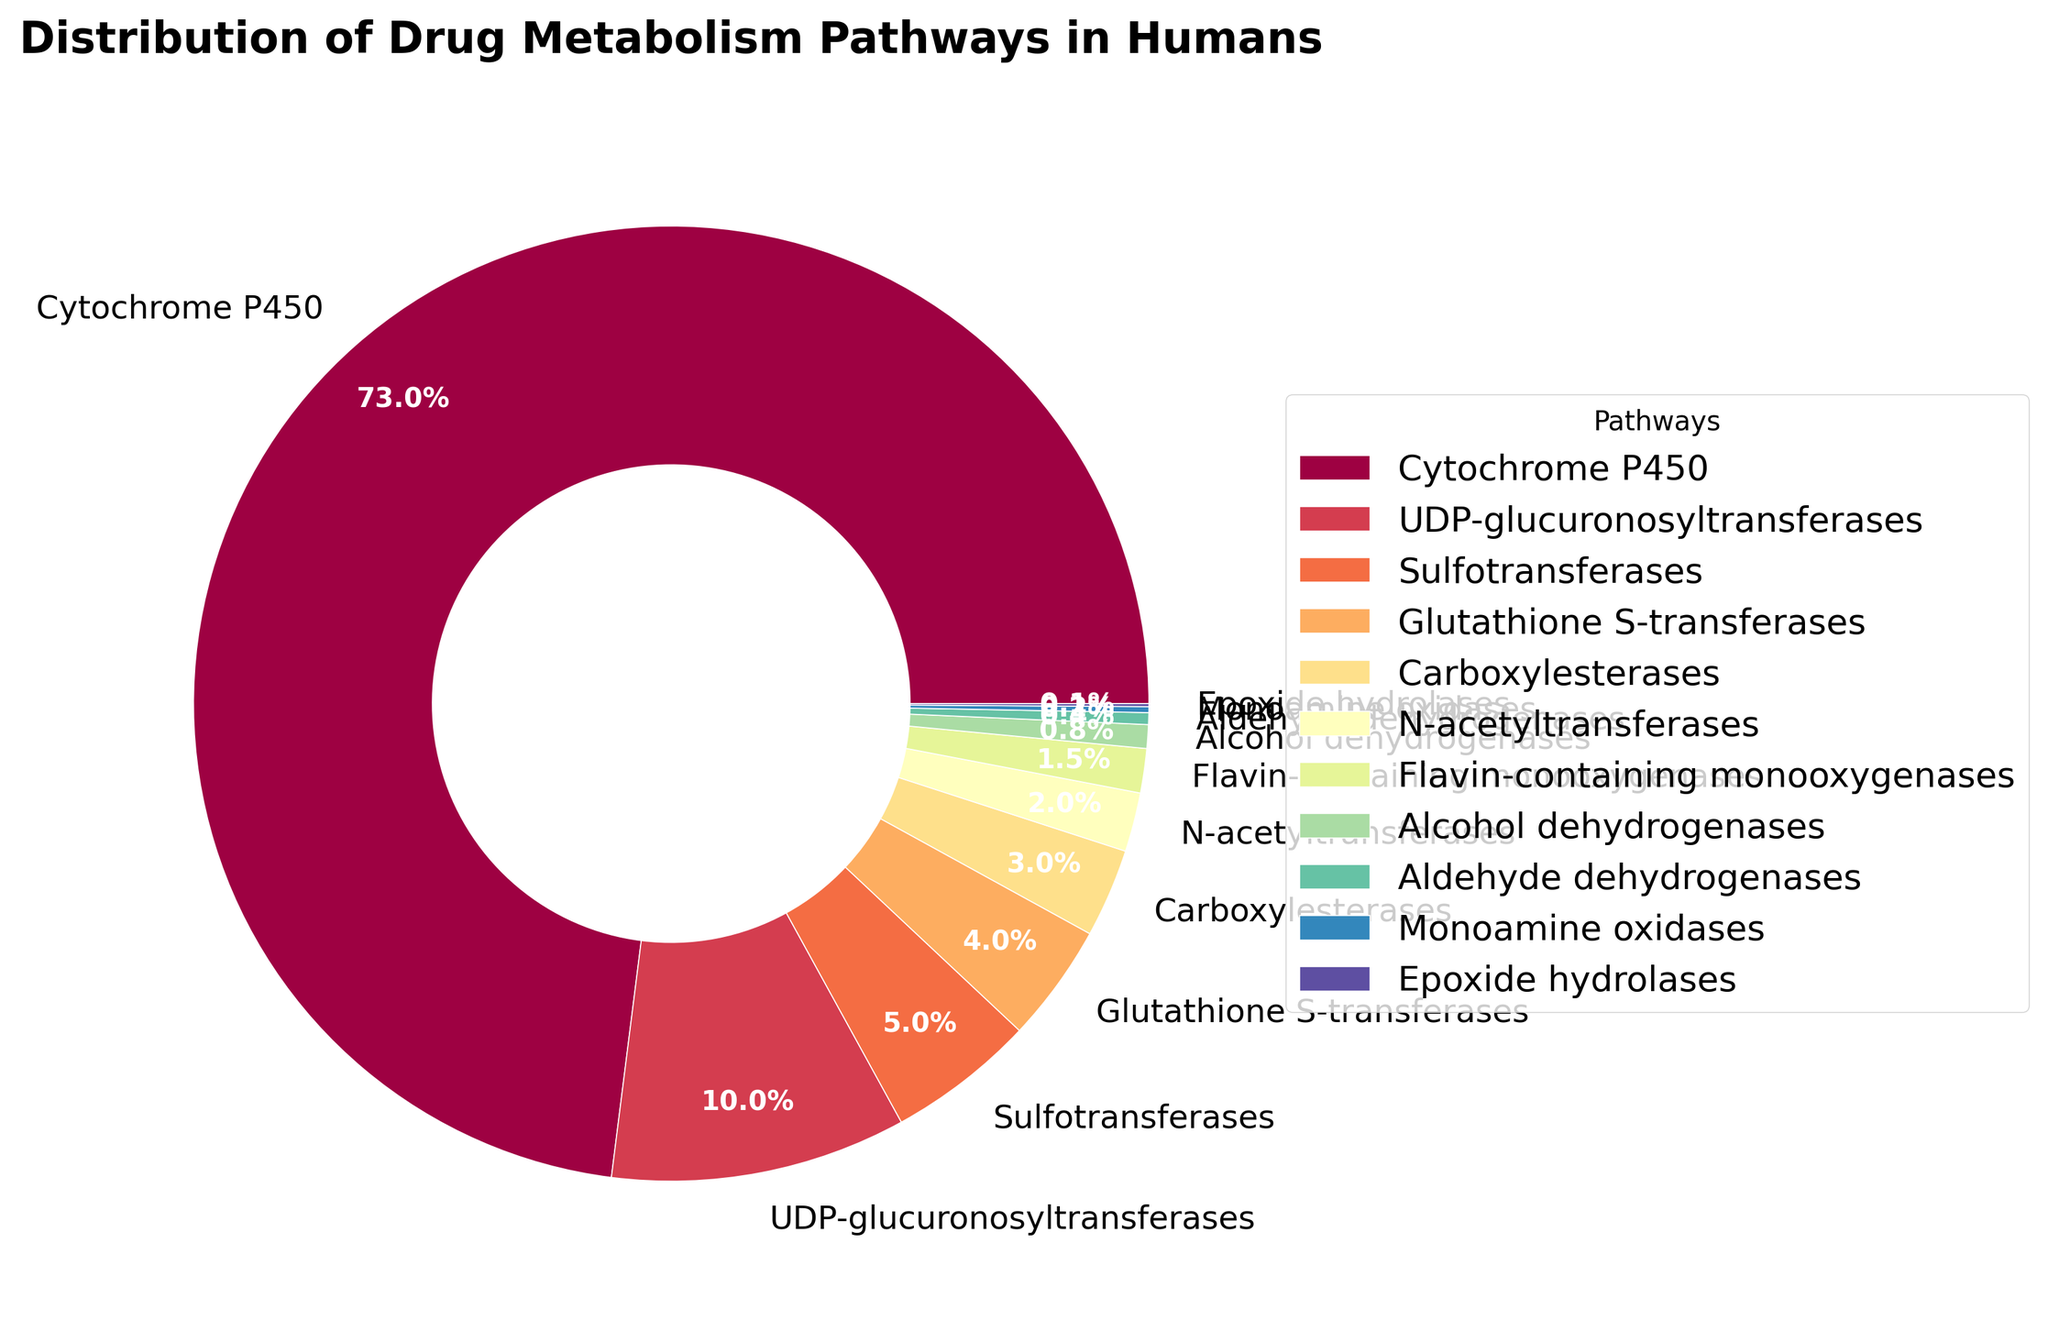Which drug metabolism pathway has the highest percentage? The largest slice of the pie chart is labeled "Cytochrome P450" with a percentage of 73%.
Answer: Cytochrome P450 What is the total percentage of pathways other than Cytochrome P450? To find this, we subtract the percentage of Cytochrome P450 (73%) from 100%. So, 100% - 73% = 27%.
Answer: 27% Which pathways have a percentage greater than or equal to 5%? The pathways with percentages labeled on the pie chart and greater than or equal to 5% are: Cytochrome P450 (73%), UDP-glucuronosyltransferases (10%), Sulfotransferases (5%).
Answer: Cytochrome P450, UDP-glucuronosyltransferases, Sulfotransferases How many pathways have a percentage less than 1% combined? The pathways with percentages less than 1% are: Flavin-containing monooxygenases (1.5%), Alcohol dehydrogenases (0.8%), Aldehyde dehydrogenases (0.4%), Monoamine oxidases (0.2%), Epoxide hydrolases (0.1%). Summing these up: 1.5% + 0.8% + 0.4% + 0.2% + 0.1% = 3%.
Answer: 3% What percentage of pathways is represented by visual wedges that appear in the lower part of the pie chart (bottom half)? The pathways appearing on the lower half of the pie chart are Glutathione S-transferases (4%), Carboxylesterases (3%), N-acetyltransferases (2%), Flavin-containing monooxygenases (1.5%), Alcohol dehydrogenases (0.8%), Aldehyde dehydrogenases (0.4%), Monoamine oxidases (0.2%), Epoxide hydrolases (0.1%), and part of Sulfotransferases (5%). Summing these up: 4% + 3% + 2% + 1.5% + 0.8% + 0.4% + 0.2% + 0.1% + 2.5% (half of 5%) = 14.5%.
Answer: 14.5% What is the ratio of the pathway with the second highest percentage to the pathway with the lowest percentage? The second highest percentage is UDP-glucuronosyltransferases (10%) and the lowest is Epoxide hydrolases (0.1%). The ratio is 10% / 0.1% = 100.
Answer: 100 